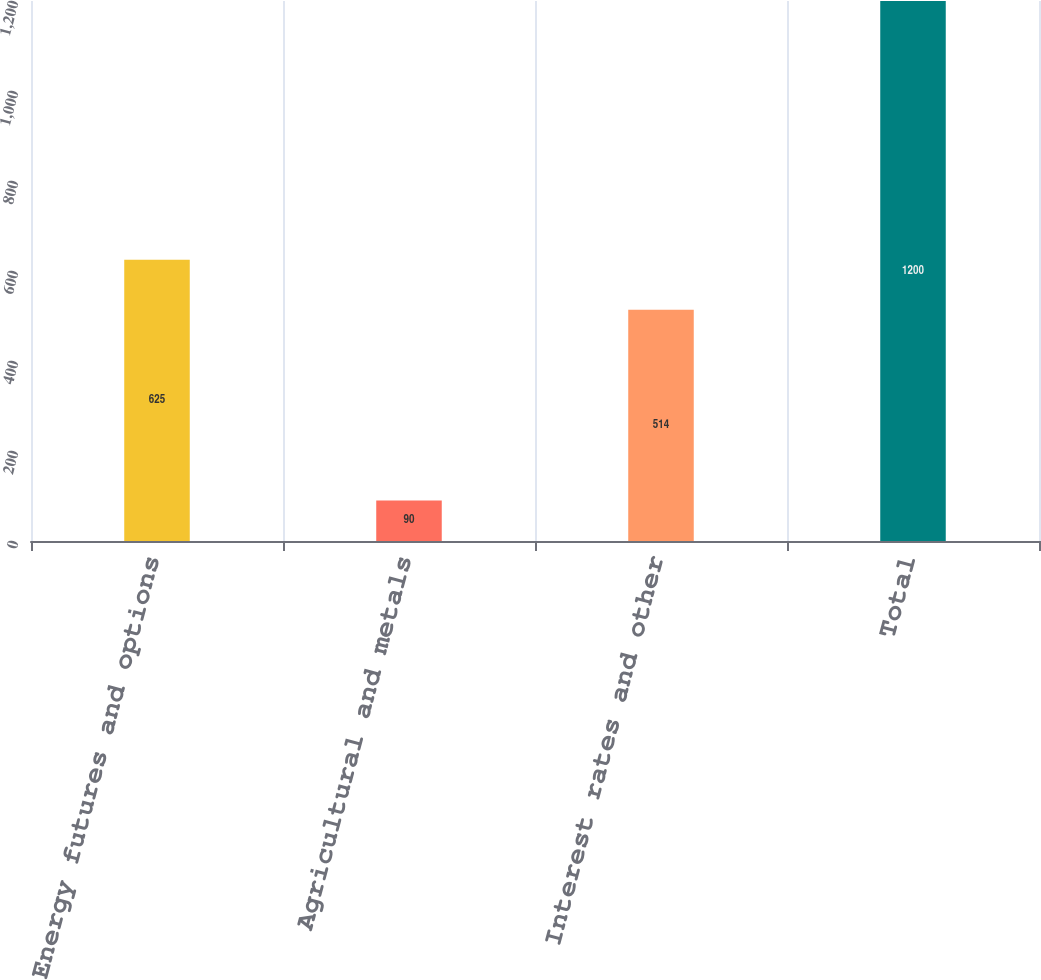Convert chart. <chart><loc_0><loc_0><loc_500><loc_500><bar_chart><fcel>Energy futures and options<fcel>Agricultural and metals<fcel>Interest rates and other<fcel>Total<nl><fcel>625<fcel>90<fcel>514<fcel>1200<nl></chart> 